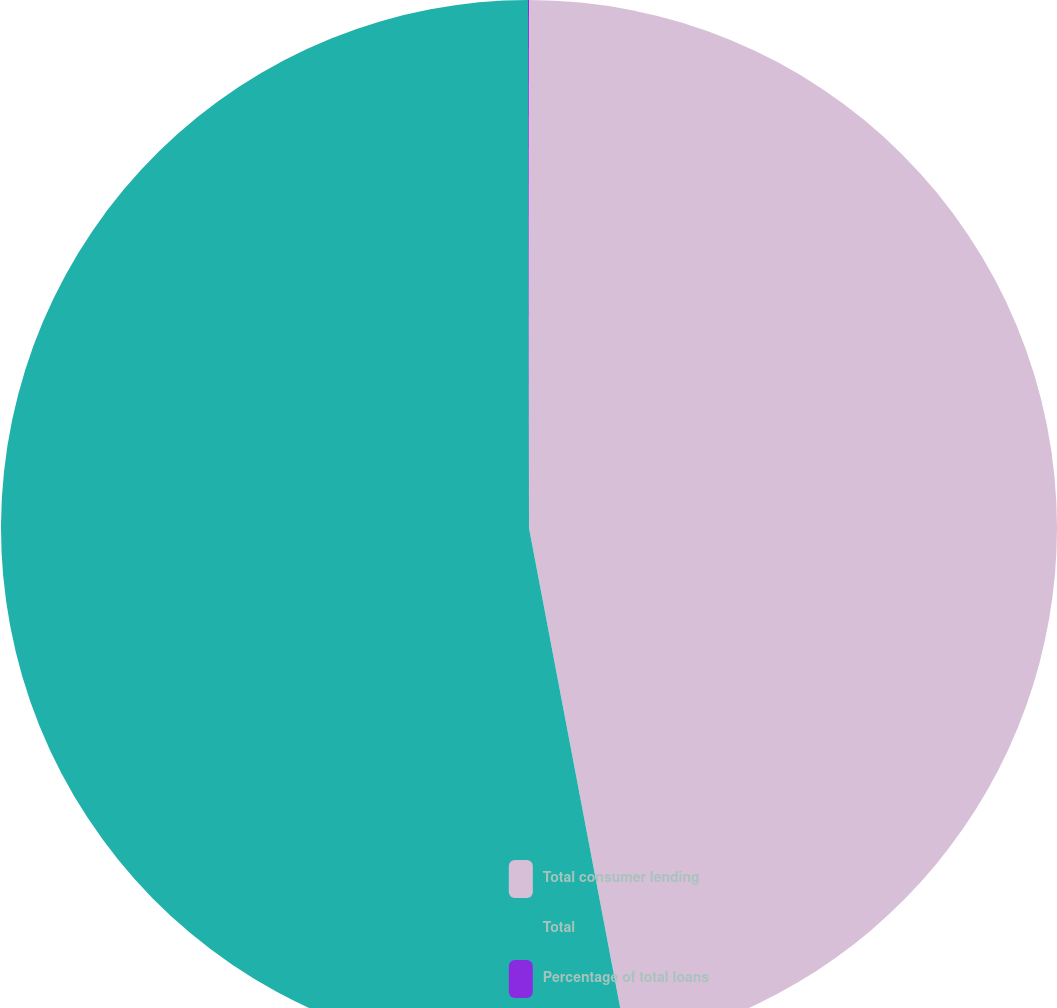Convert chart. <chart><loc_0><loc_0><loc_500><loc_500><pie_chart><fcel>Total consumer lending<fcel>Total<fcel>Percentage of total loans<nl><fcel>47.01%<fcel>52.96%<fcel>0.03%<nl></chart> 